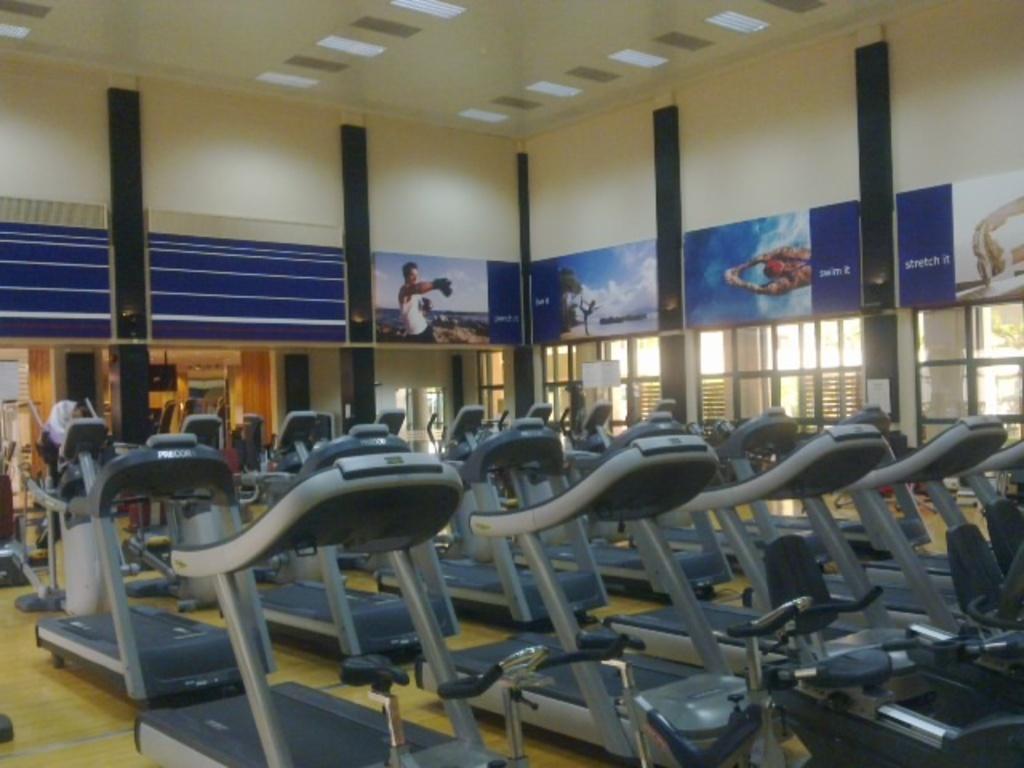Can you describe this image briefly? In this image we can see a group of treadmills placed on the floor. On the backside we can see a person on a treadmill, a wall with some pictures on it, some pillars and a roof. 